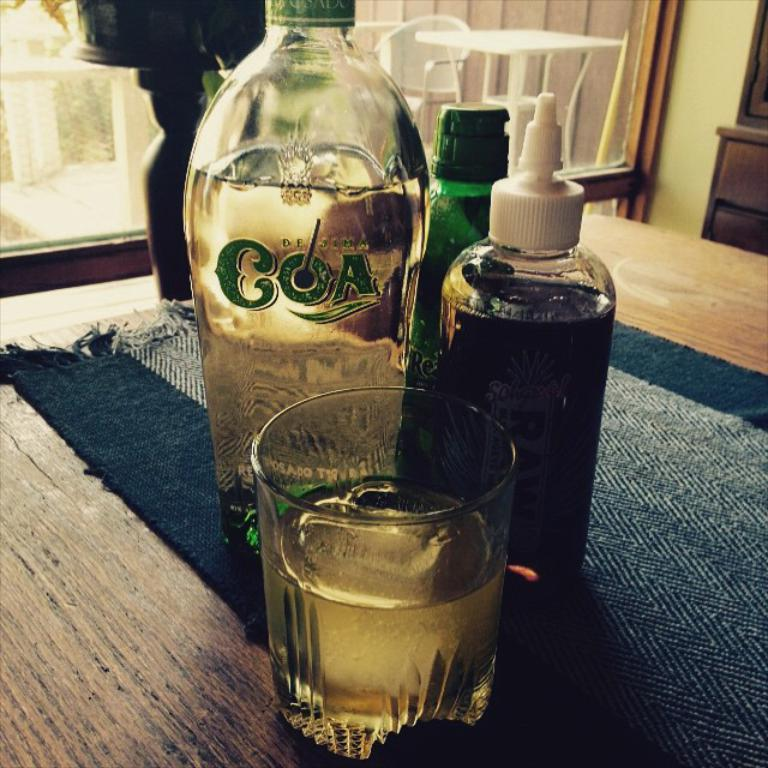What is on the table in the image? There is a bottle and a glass on the table. Can you describe the bottle and the glass? The facts provided do not give specific details about the bottle and the glass, but they are both objects that can hold liquids. What type of trousers is the person wearing in the image? There is no person present in the image, so it is not possible to determine what type of trousers they might be wearing. 